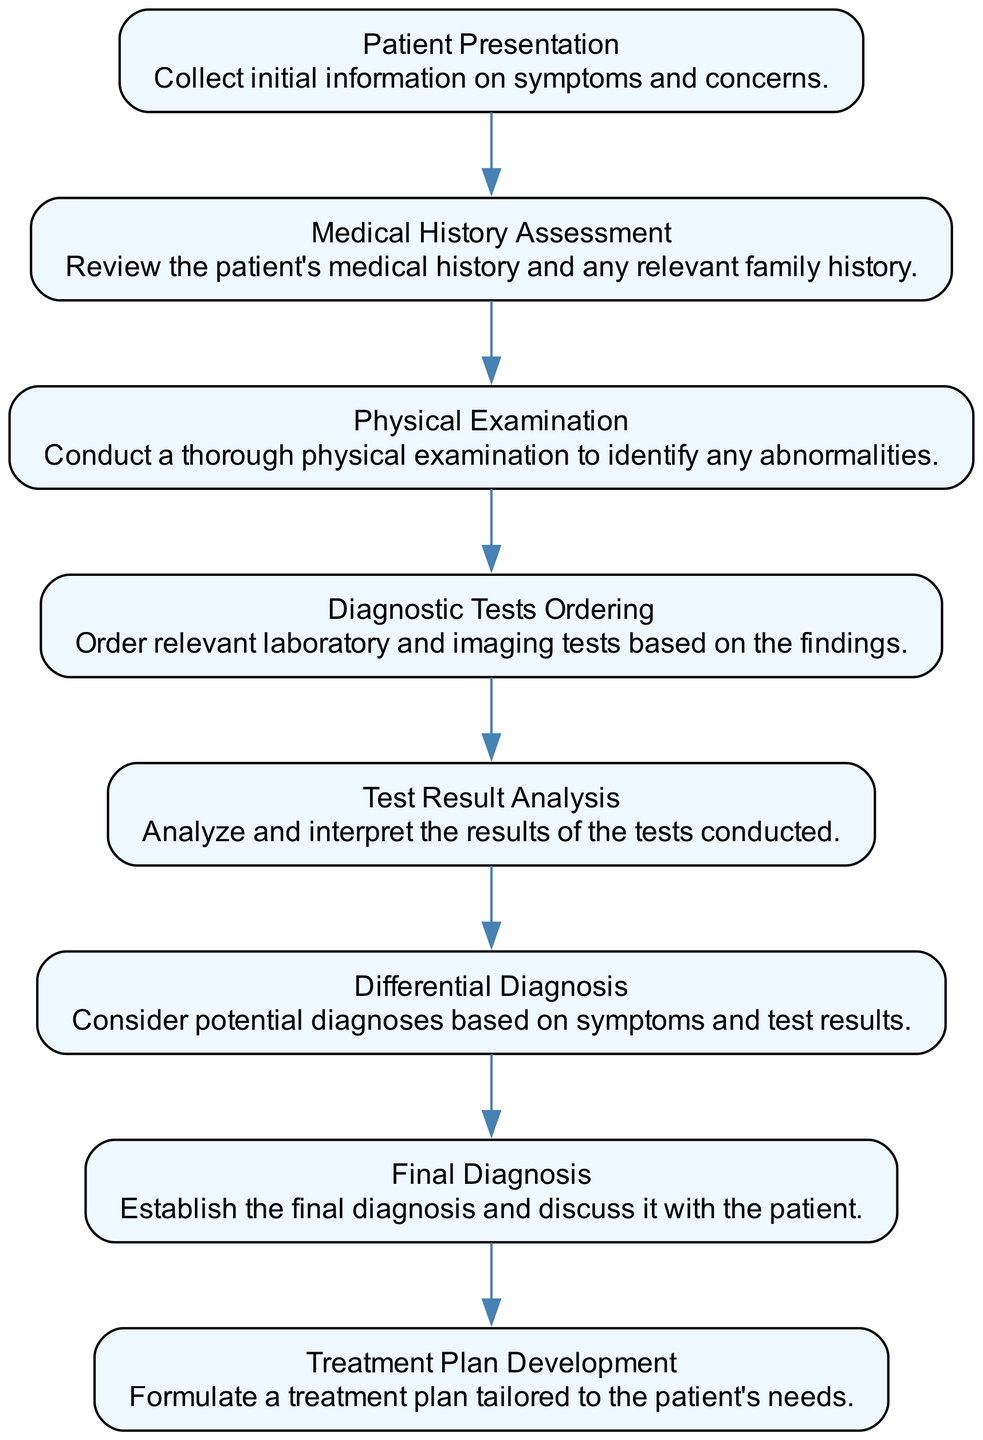What is the first step in the diagnosis process? The first step is "Patient Presentation," where initial information on symptoms and concerns is collected.
Answer: Patient Presentation How many steps are there in total? There are eight steps involved in diagnosing a common ailment, as indicated by the eight nodes in the diagram.
Answer: 8 What is the last step in the process? The last step is "Treatment Plan Development," where a treatment plan tailored to the patient's needs is formulated.
Answer: Treatment Plan Development What comes after "Test Result Analysis"? After "Test Result Analysis," the next step is "Differential Diagnosis," where potential diagnoses are considered based on the symptoms and test results.
Answer: Differential Diagnosis Which step involves reviewing the patient's medical history? The step that involves reviewing the patient's medical history is "Medical History Assessment."
Answer: Medical History Assessment What is the relationship between "Physical Examination" and "Test Result Analysis"? "Physical Examination" precedes "Diagnostic Tests Ordering," which leads to "Test Result Analysis" as part of the diagnostic process.
Answer: Sequential What type of examinations are conducted in the "Physical Examination" step? A thorough physical examination is conducted to identify any abnormalities as part of this step.
Answer: Thorough physical examination How is the final diagnosis established? The final diagnosis is established after analyzing the test results and considering potential diagnoses based on symptoms and test results.
Answer: Final Diagnosis What does the "Diagnostic Tests Ordering" step involve? This step involves ordering relevant laboratory and imaging tests based on findings from previous steps.
Answer: Ordering tests 